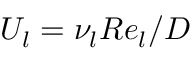<formula> <loc_0><loc_0><loc_500><loc_500>U _ { l } = \nu _ { l } R e _ { l } / D</formula> 